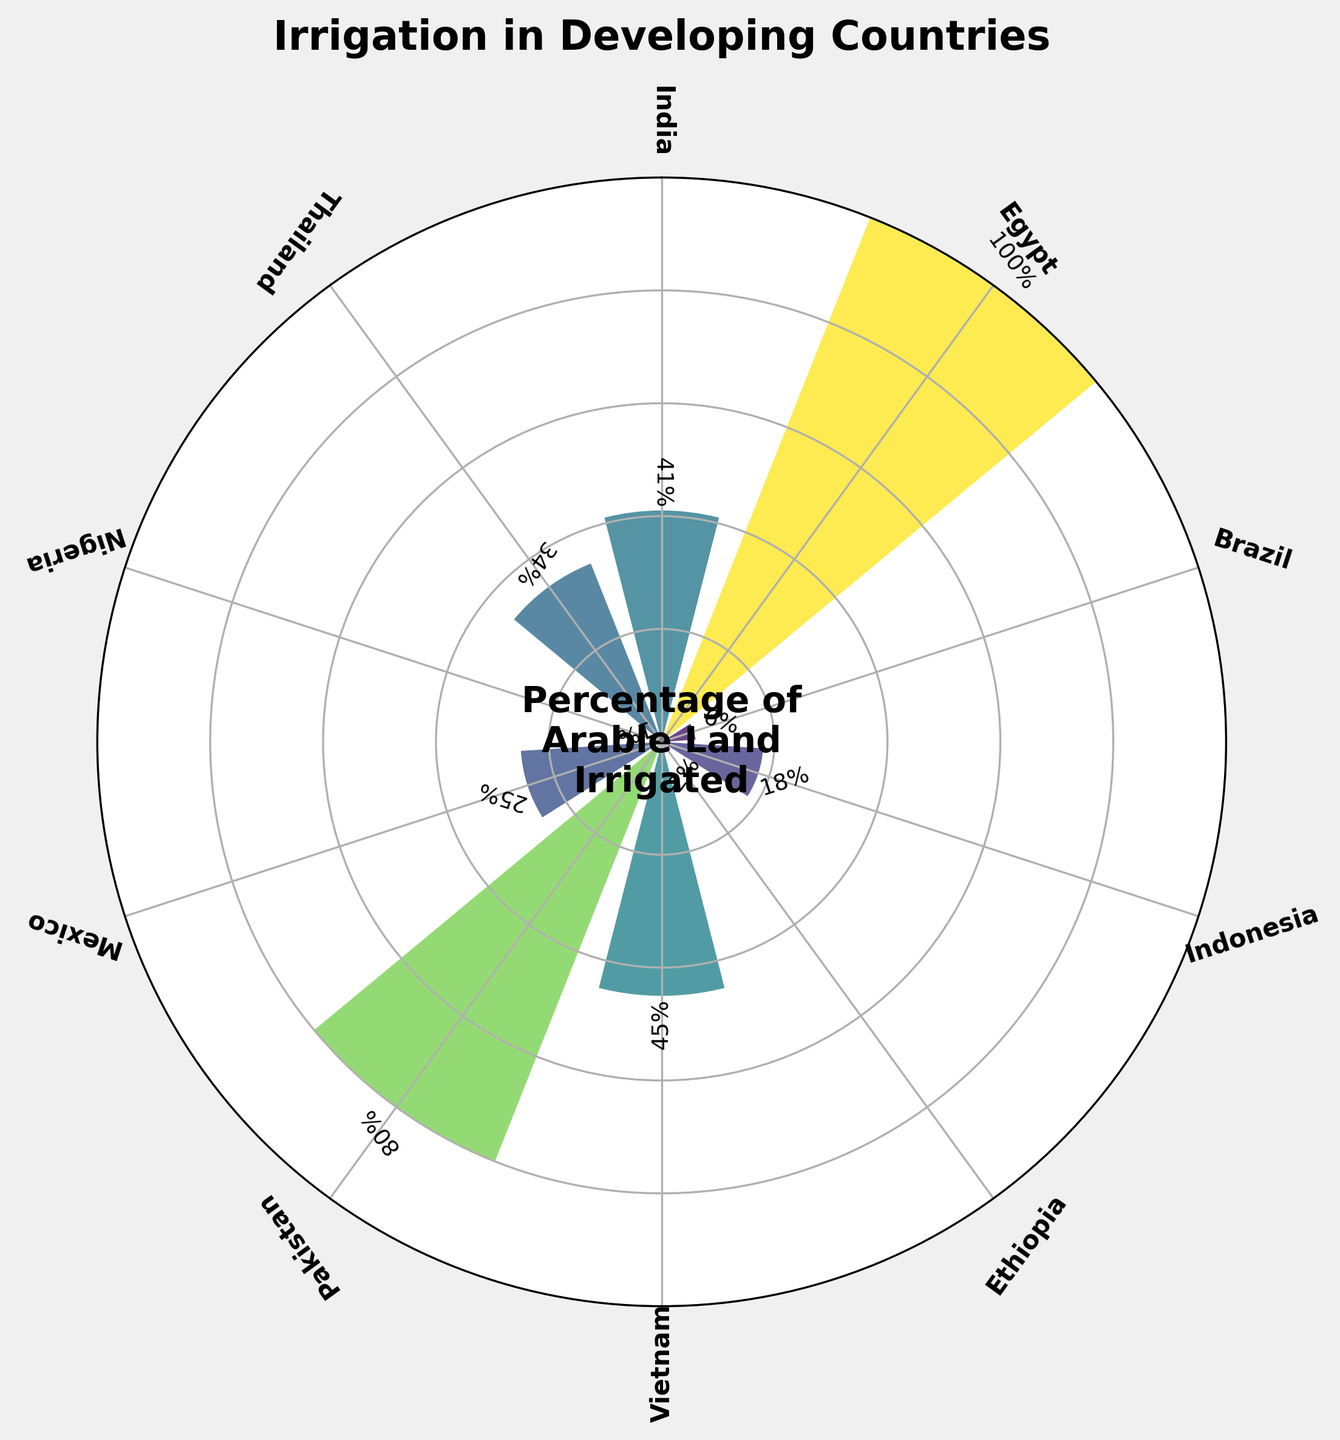What is the title of the chart? The title is positioned at the top of the chart and can be read directly.
Answer: Irrigation in Developing Countries How many countries are represented in the chart? By counting the individual country names around the circular chart, we can see there are 10 countries.
Answer: 10 Which country has the highest percentage of irrigated arable land? The chart shows that Egypt has the highest bar reaching 100%, which is also explicitly labeled.
Answer: Egypt Which country has the lowest percentage of irrigated arable land? Nigeria has the lowest bar, barely above the bottom circle, and it is labeled as 1%.
Answer: Nigeria What is the average percentage of arable land irrigated across all the countries? Sum the percentages (41 + 100 + 6 + 18 + 2 + 45 + 80 + 25 + 1 + 34) which equals 352, then divide by the number of countries (10).
Answer: 35.2 Which countries have a percentage of irrigated arable land greater than 40%? From the chart, the countries with percentages greater than 40% are India, Egypt, Vietnam, and Pakistan.
Answer: India, Egypt, Vietnam, Pakistan What is the difference in the percentage of irrigated arable land between Vietnam and Brazil? Vietnam's percentage is 45% and Brazil's is 6%. Subtracting 6 from 45 gives 39.
Answer: 39 What is the median percentage of irrigated arable land? List the percentages in ascending order (1, 2, 6, 18, 25, 34, 41, 45, 80, 100). The median is the middle value (25 + 34) / 2.
Answer: 29.5 How many countries have less than 20% of their arable land irrigated? Countries with less than 20% are Brazil, Indonesia, Ethiopia, and Nigeria. Counting these gives 4.
Answer: 4 Between Mexico and Thailand, which country has a higher percentage of irrigated arable land? Thailand's percentage is 34%, while Mexico's is 25%. Thus, Thailand has a higher percentage.
Answer: Thailand 